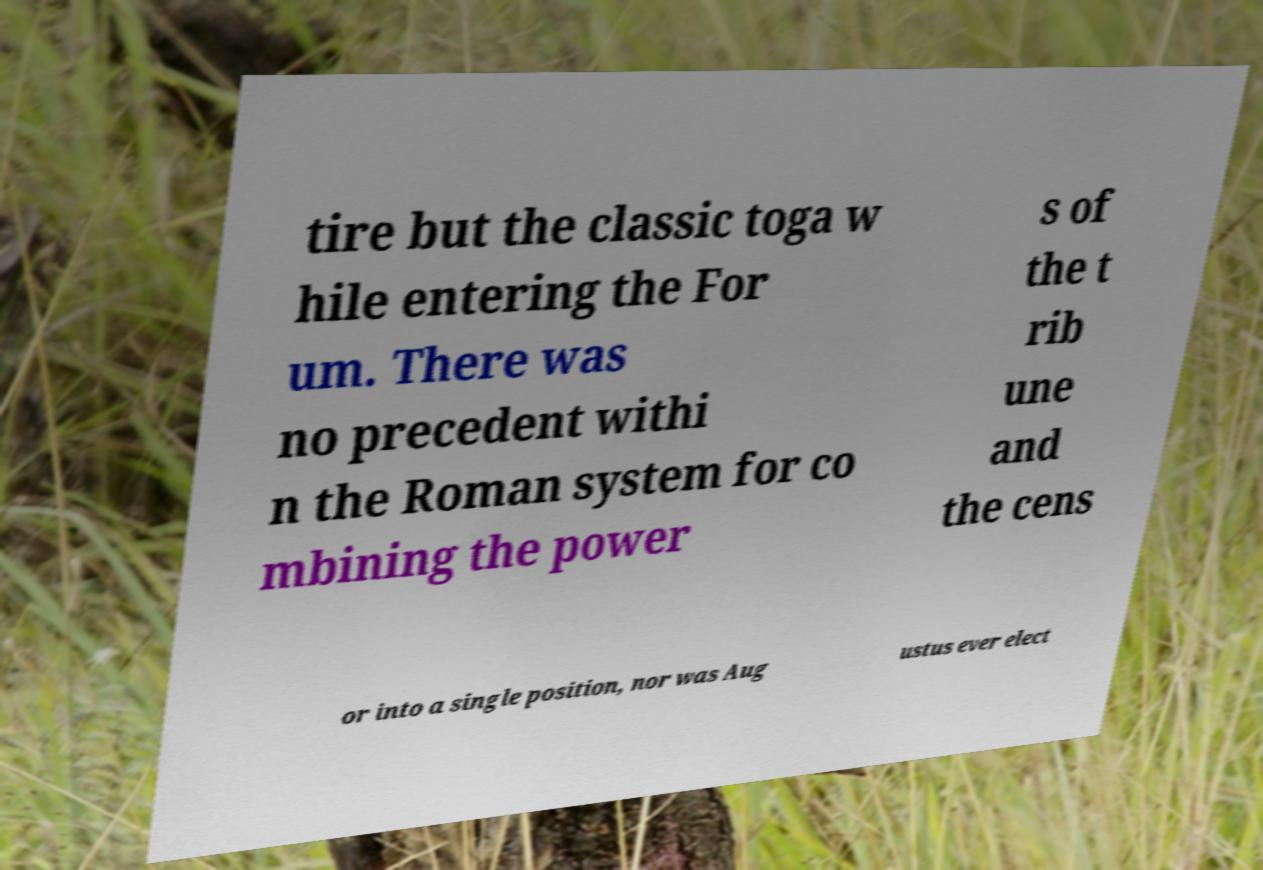Please identify and transcribe the text found in this image. tire but the classic toga w hile entering the For um. There was no precedent withi n the Roman system for co mbining the power s of the t rib une and the cens or into a single position, nor was Aug ustus ever elect 